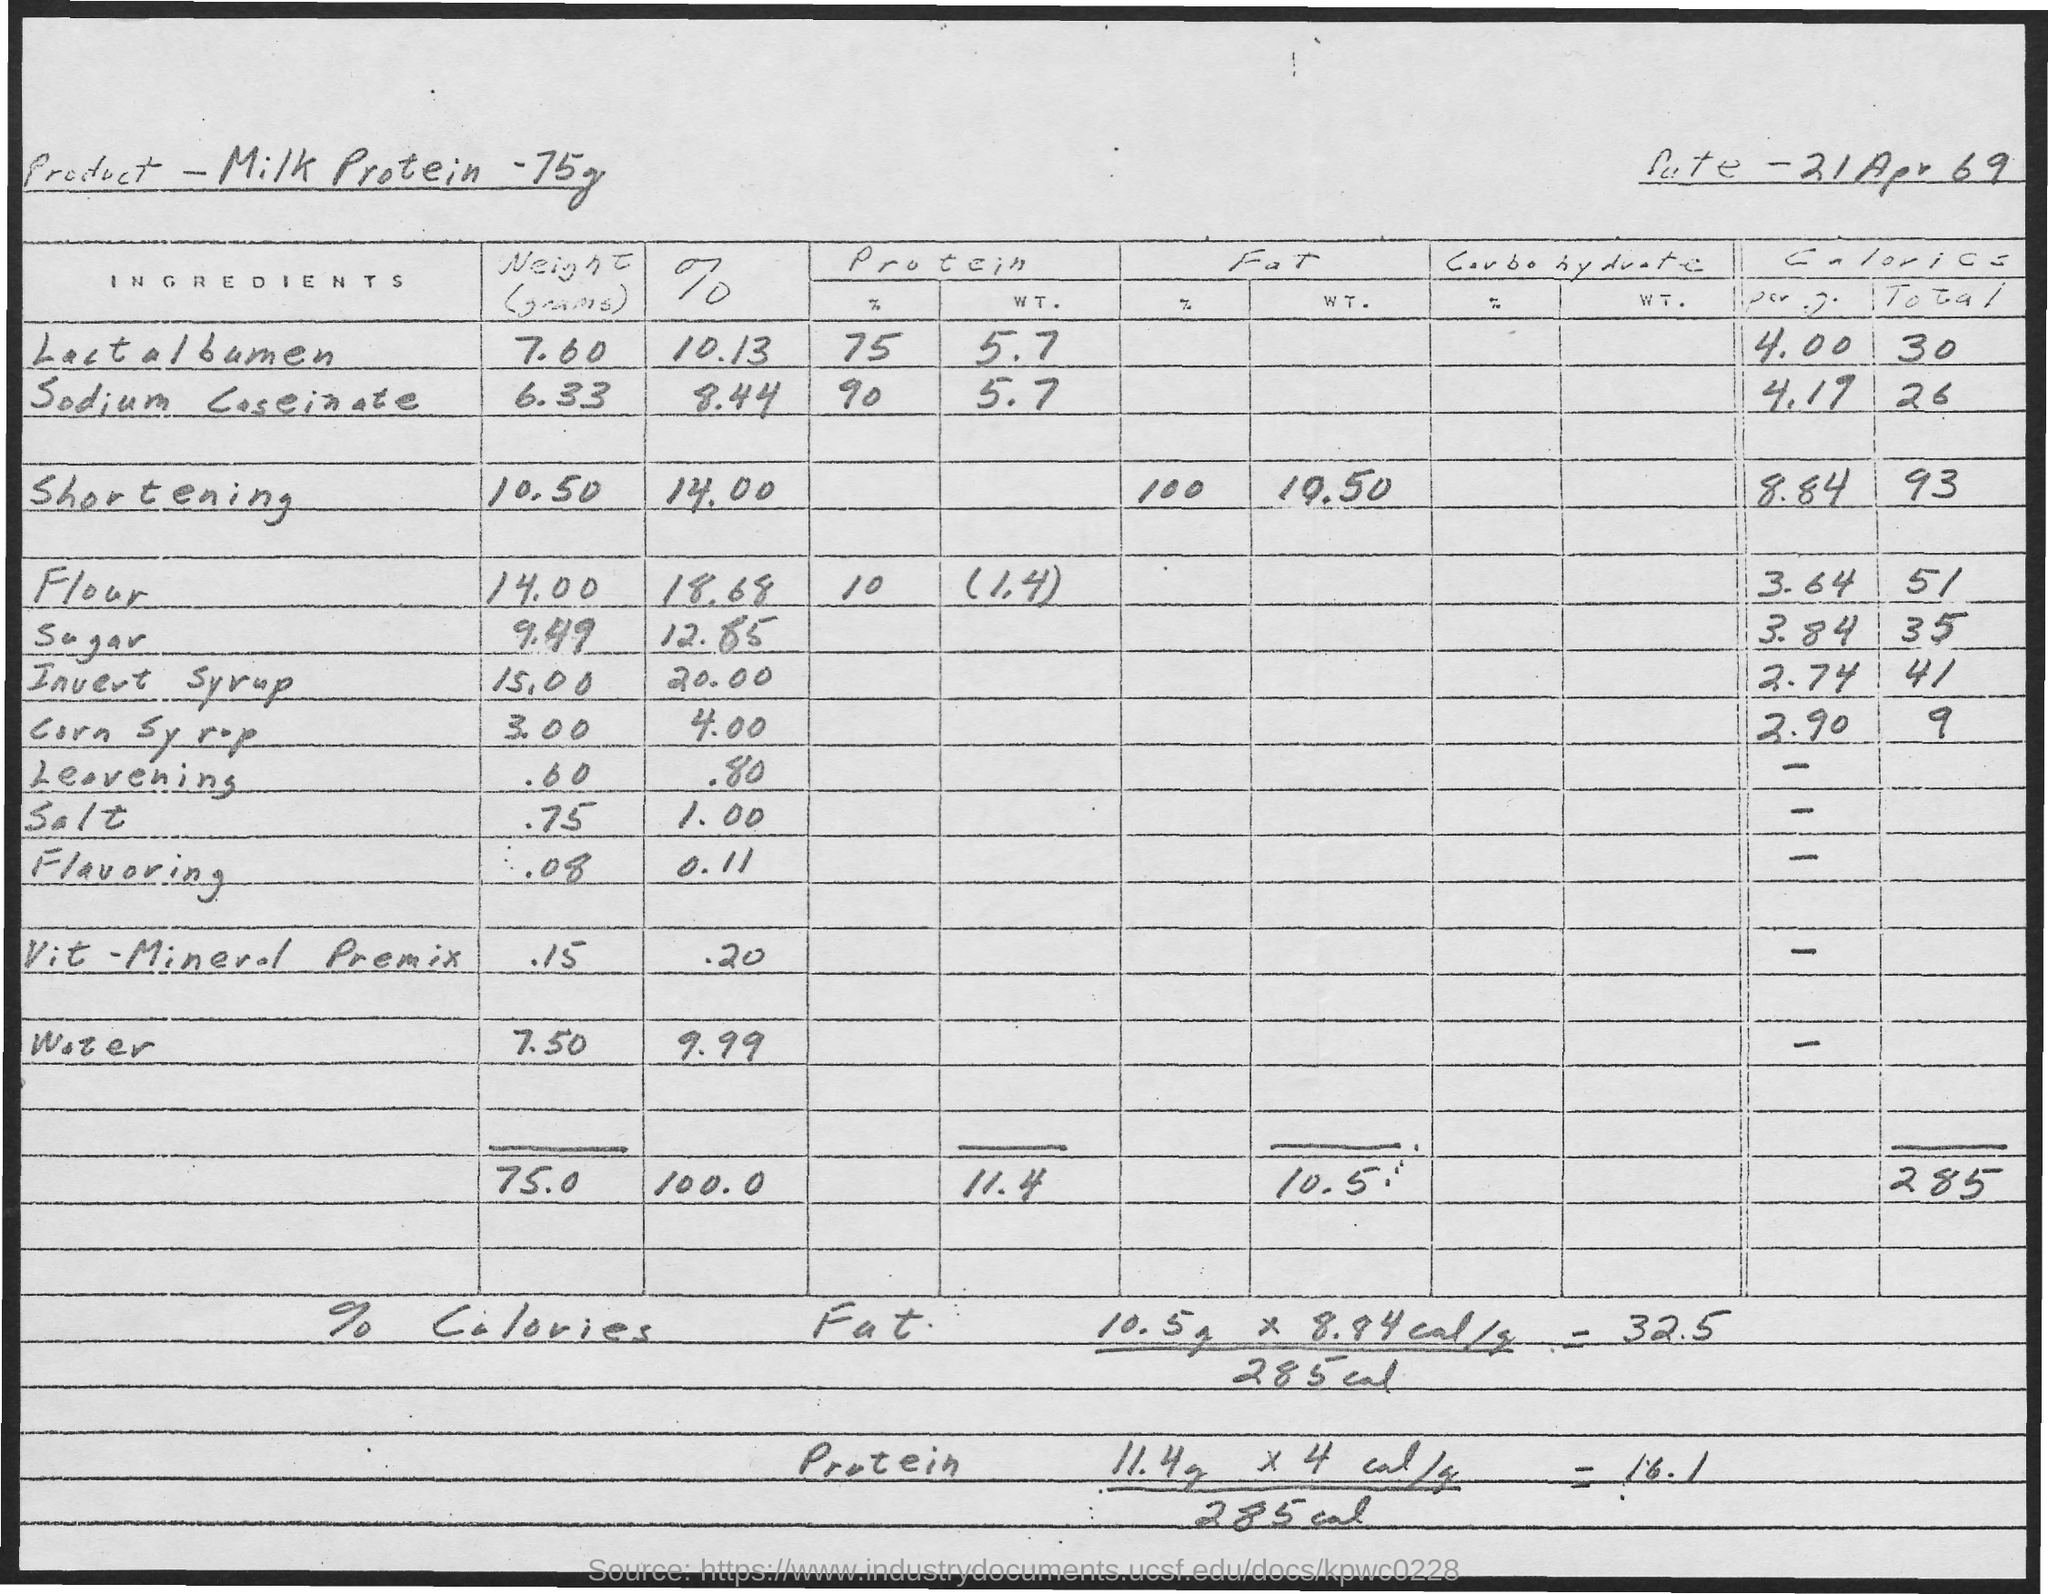Point out several critical features in this image. The milk protein contains 14.00% shortening. The percentage of lactalbumin in milk protein is 10.13%. Lactalbumin is a type of milk protein that weighs approximately 75 grams. The weight of flour in milk protein is 75 grams, and the total weight of both is 140 grams. The weight of shortening in Milk protein is 75 grams, and the value is 10.50. 